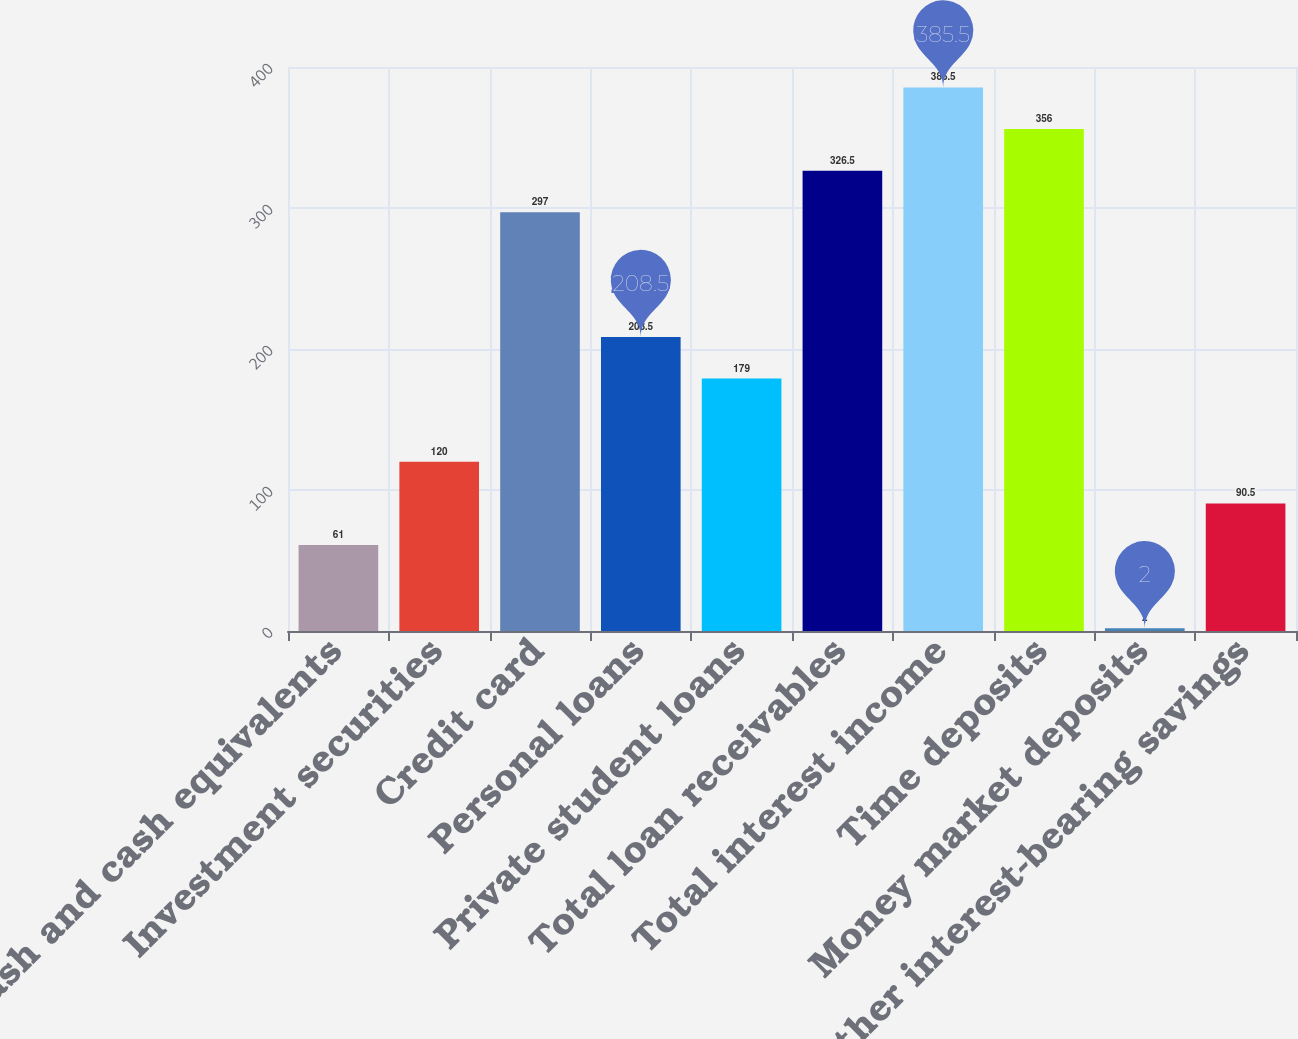Convert chart. <chart><loc_0><loc_0><loc_500><loc_500><bar_chart><fcel>Cash and cash equivalents<fcel>Investment securities<fcel>Credit card<fcel>Personal loans<fcel>Private student loans<fcel>Total loan receivables<fcel>Total interest income<fcel>Time deposits<fcel>Money market deposits<fcel>Other interest-bearing savings<nl><fcel>61<fcel>120<fcel>297<fcel>208.5<fcel>179<fcel>326.5<fcel>385.5<fcel>356<fcel>2<fcel>90.5<nl></chart> 